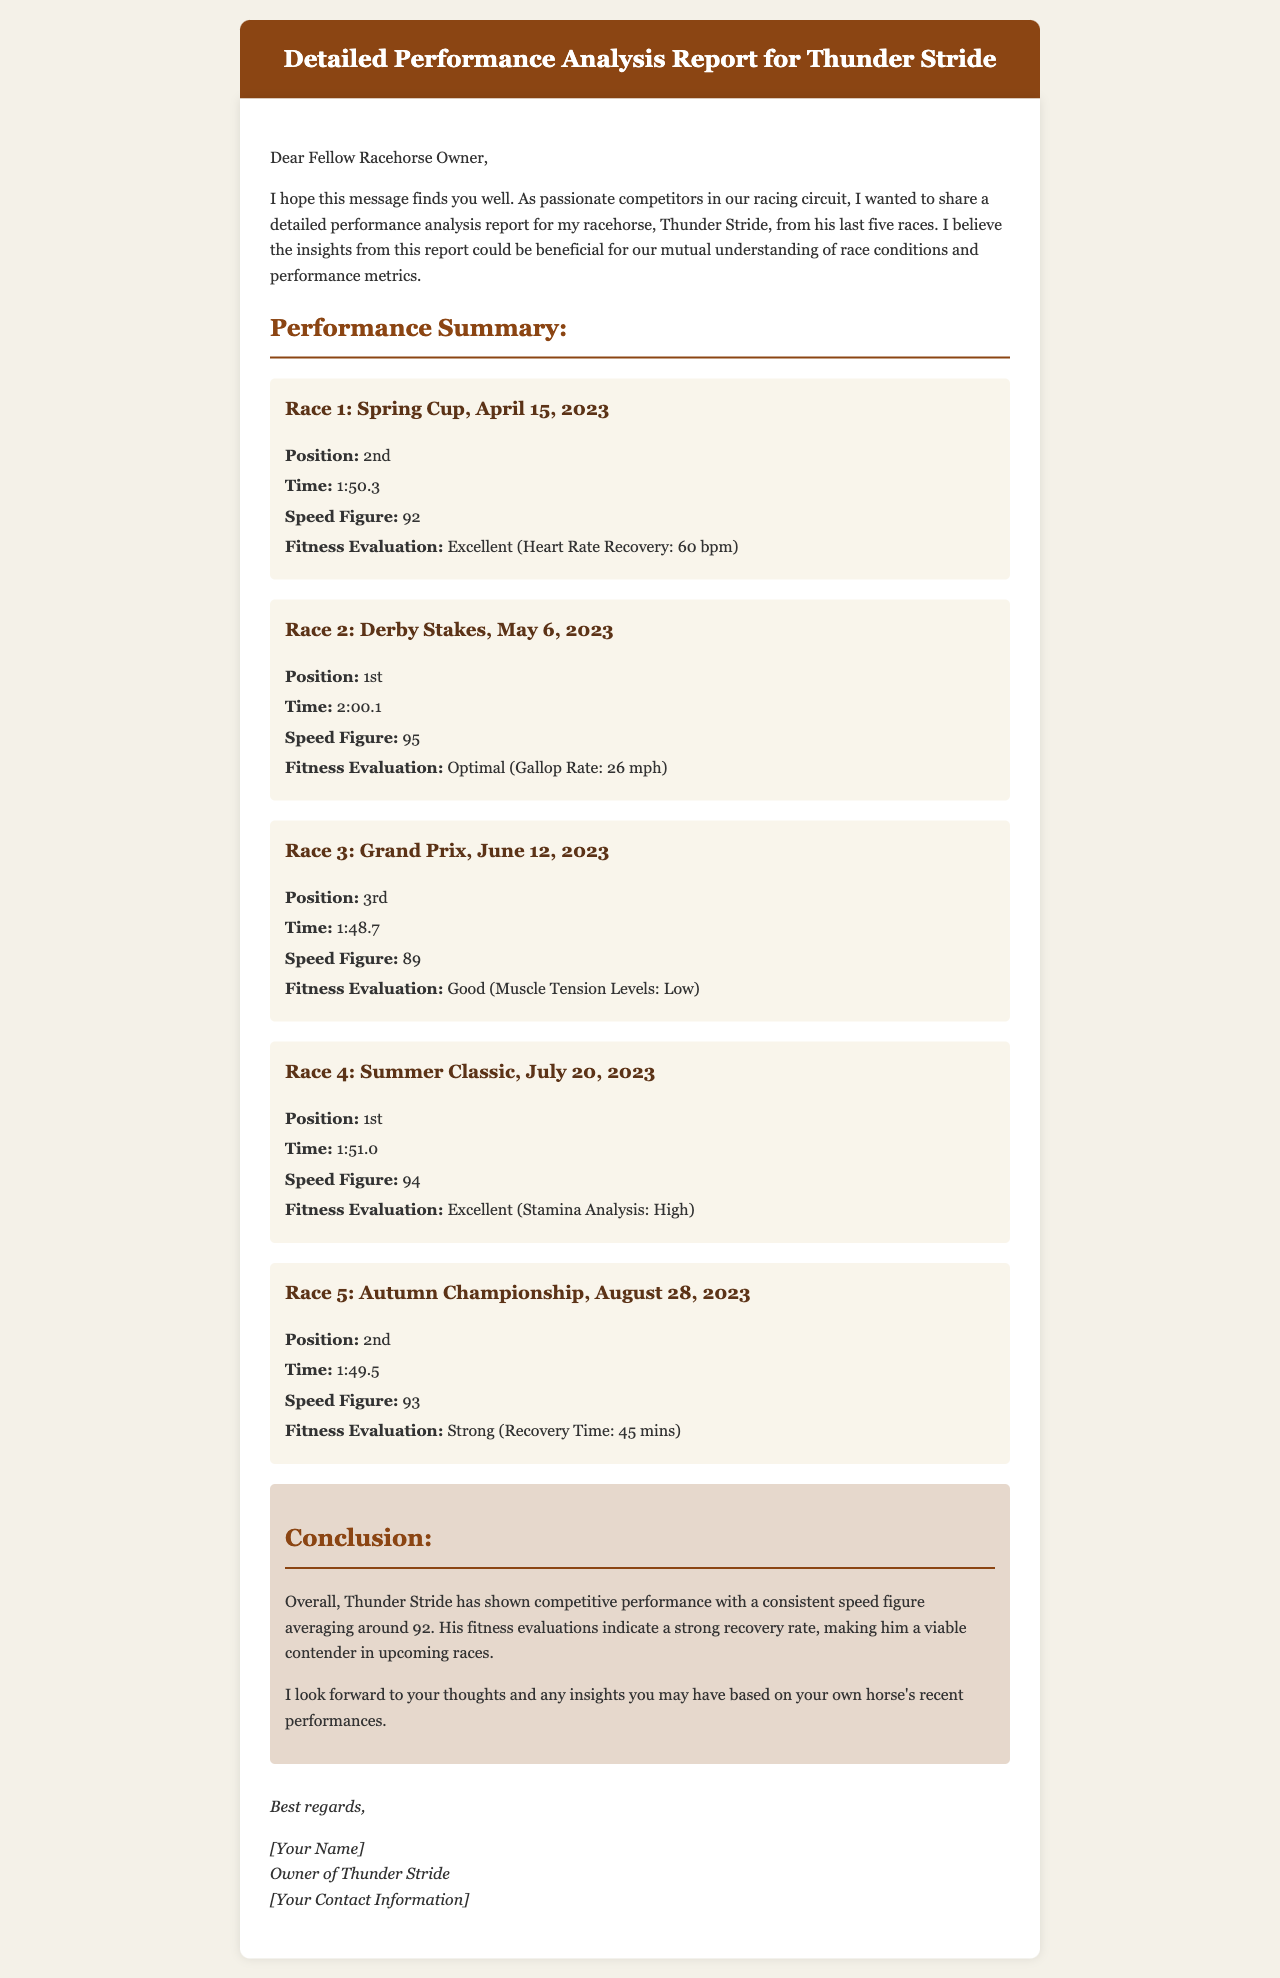What position did Thunder Stride finish in the Spring Cup? The document states that Thunder Stride finished in 2nd position in the Spring Cup.
Answer: 2nd What was the time taken by Thunder Stride in the Derby Stakes? The time recorded for Thunder Stride in the Derby Stakes is mentioned as 2:00.1.
Answer: 2:00.1 What was Thunder Stride's average speed figure over the last five races? The document mentions that Thunder Stride's average speed figure is approximately 92.
Answer: 92 In which race did Thunder Stride achieve the highest speed figure? The Derby Stakes was the race where Thunder Stride achieved the highest speed figure of 95.
Answer: Derby Stakes What fitness evaluation was given after the Autumn Championship? The fitness evaluation shown after the Autumn Championship is "Strong."
Answer: Strong How many races did Thunder Stride finish in the top 3? Thunder Stride finished in the top 3 in 4 out of 5 races, as indicated in the document.
Answer: 4 Which race had the fastest time recorded by Thunder Stride? In the Grand Prix, Thunder Stride recorded the fastest time of 1:48.7.
Answer: Grand Prix What is the conclusion about Thunder Stride's fitness evaluations? The conclusion states that Thunder Stride's fitness evaluations indicate a strong recovery rate.
Answer: Strong recovery rate 